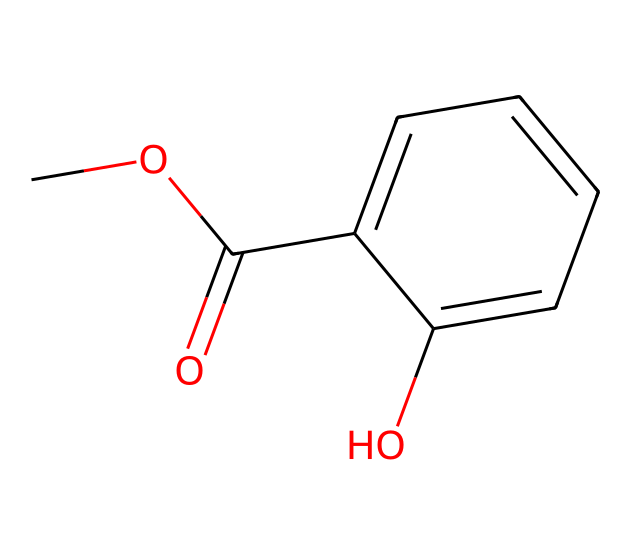What is the name of the chemical represented by this SMILES? The SMILES code corresponds to methyl salicylate, which is a known compound with the structure indicated in the representation.
Answer: methyl salicylate How many carbon atoms are present in methyl salicylate? Counting the carbon atoms in the SMILES, there are a total of 9 carbon atoms present in the structure.
Answer: 9 What type of functional group does methyl salicylate contain? The presence of an ester functional group, indicated by the carbonyl (C=O) and the ether (C-O-C) connection in the structure, shows that it is an ester.
Answer: ester What is the total number of oxygen atoms in methyl salicylate? By examining the structure in the SMILES notation, one can identify that there are 2 oxygen atoms present within the molecule.
Answer: 2 Which cyclic structure is present in methyl salicylate? The structure contains a benzene ring, a common cyclic structure seen in many aromatic compounds, as indicated by the alternating double bonds.
Answer: benzene What characteristic of methyl salicylate is responsible for its use in perfumery? The presence of the aromatic benzene ring, along with the ester link, gives methyl salicylate its pleasant fragrance, making it suitable for use in perfumes.
Answer: pleasant fragrance 